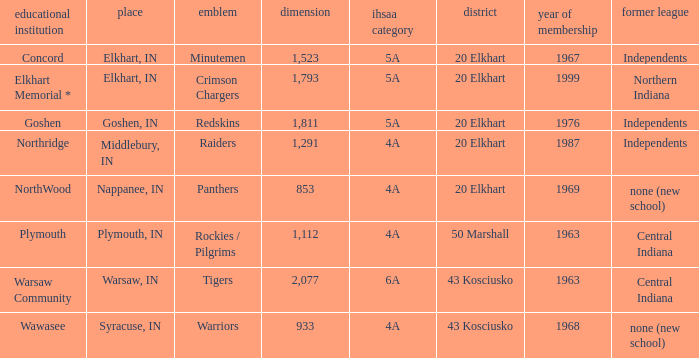Which country enrolled before 1976, featuring an ihssa classification of 5a, and a dimension bigger than 1,112? 20 Elkhart. 